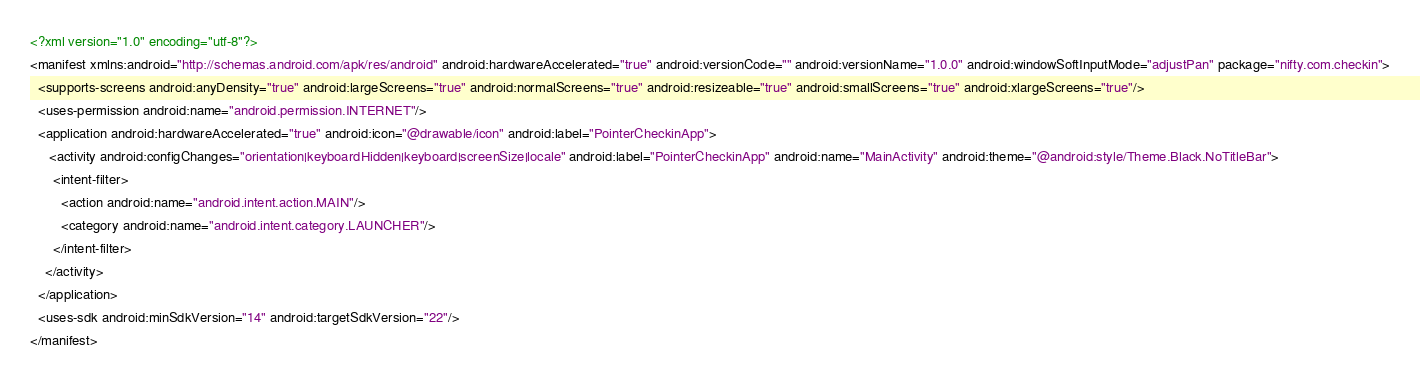<code> <loc_0><loc_0><loc_500><loc_500><_XML_><?xml version="1.0" encoding="utf-8"?>
<manifest xmlns:android="http://schemas.android.com/apk/res/android" android:hardwareAccelerated="true" android:versionCode="" android:versionName="1.0.0" android:windowSoftInputMode="adjustPan" package="nifty.com.checkin">
  <supports-screens android:anyDensity="true" android:largeScreens="true" android:normalScreens="true" android:resizeable="true" android:smallScreens="true" android:xlargeScreens="true"/>
  <uses-permission android:name="android.permission.INTERNET"/>
  <application android:hardwareAccelerated="true" android:icon="@drawable/icon" android:label="PointerCheckinApp">
     <activity android:configChanges="orientation|keyboardHidden|keyboard|screenSize|locale" android:label="PointerCheckinApp" android:name="MainActivity" android:theme="@android:style/Theme.Black.NoTitleBar">
      <intent-filter>
        <action android:name="android.intent.action.MAIN"/>
        <category android:name="android.intent.category.LAUNCHER"/>
      </intent-filter>
    </activity>
  </application>
  <uses-sdk android:minSdkVersion="14" android:targetSdkVersion="22"/>
</manifest>
</code> 